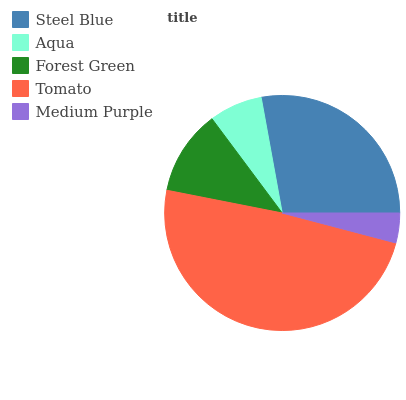Is Medium Purple the minimum?
Answer yes or no. Yes. Is Tomato the maximum?
Answer yes or no. Yes. Is Aqua the minimum?
Answer yes or no. No. Is Aqua the maximum?
Answer yes or no. No. Is Steel Blue greater than Aqua?
Answer yes or no. Yes. Is Aqua less than Steel Blue?
Answer yes or no. Yes. Is Aqua greater than Steel Blue?
Answer yes or no. No. Is Steel Blue less than Aqua?
Answer yes or no. No. Is Forest Green the high median?
Answer yes or no. Yes. Is Forest Green the low median?
Answer yes or no. Yes. Is Medium Purple the high median?
Answer yes or no. No. Is Tomato the low median?
Answer yes or no. No. 